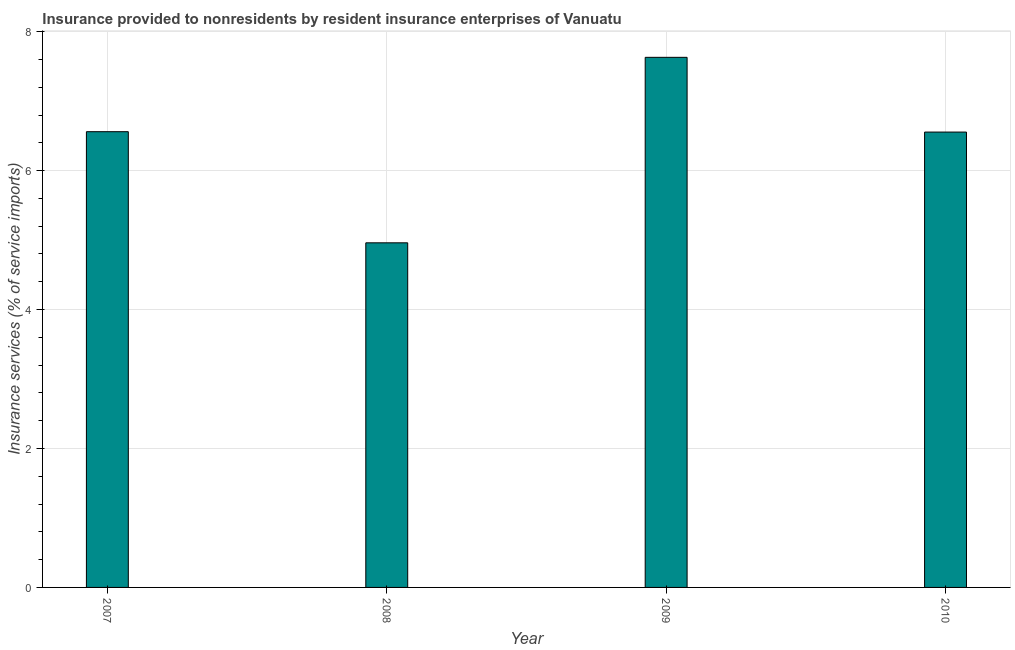Does the graph contain any zero values?
Offer a terse response. No. What is the title of the graph?
Make the answer very short. Insurance provided to nonresidents by resident insurance enterprises of Vanuatu. What is the label or title of the Y-axis?
Keep it short and to the point. Insurance services (% of service imports). What is the insurance and financial services in 2009?
Give a very brief answer. 7.63. Across all years, what is the maximum insurance and financial services?
Keep it short and to the point. 7.63. Across all years, what is the minimum insurance and financial services?
Offer a terse response. 4.96. In which year was the insurance and financial services minimum?
Provide a succinct answer. 2008. What is the sum of the insurance and financial services?
Your answer should be compact. 25.71. What is the difference between the insurance and financial services in 2007 and 2009?
Offer a terse response. -1.07. What is the average insurance and financial services per year?
Offer a very short reply. 6.43. What is the median insurance and financial services?
Offer a terse response. 6.56. Do a majority of the years between 2008 and 2009 (inclusive) have insurance and financial services greater than 5.6 %?
Give a very brief answer. No. What is the ratio of the insurance and financial services in 2007 to that in 2009?
Offer a terse response. 0.86. Is the insurance and financial services in 2008 less than that in 2010?
Give a very brief answer. Yes. What is the difference between the highest and the second highest insurance and financial services?
Your response must be concise. 1.07. Is the sum of the insurance and financial services in 2007 and 2009 greater than the maximum insurance and financial services across all years?
Your answer should be compact. Yes. What is the difference between the highest and the lowest insurance and financial services?
Keep it short and to the point. 2.67. How many bars are there?
Provide a short and direct response. 4. What is the difference between two consecutive major ticks on the Y-axis?
Your response must be concise. 2. What is the Insurance services (% of service imports) in 2007?
Provide a short and direct response. 6.56. What is the Insurance services (% of service imports) of 2008?
Offer a terse response. 4.96. What is the Insurance services (% of service imports) of 2009?
Your answer should be compact. 7.63. What is the Insurance services (% of service imports) in 2010?
Provide a succinct answer. 6.55. What is the difference between the Insurance services (% of service imports) in 2007 and 2008?
Your answer should be very brief. 1.6. What is the difference between the Insurance services (% of service imports) in 2007 and 2009?
Offer a very short reply. -1.07. What is the difference between the Insurance services (% of service imports) in 2007 and 2010?
Offer a very short reply. 0.01. What is the difference between the Insurance services (% of service imports) in 2008 and 2009?
Offer a terse response. -2.67. What is the difference between the Insurance services (% of service imports) in 2008 and 2010?
Give a very brief answer. -1.59. What is the difference between the Insurance services (% of service imports) in 2009 and 2010?
Give a very brief answer. 1.08. What is the ratio of the Insurance services (% of service imports) in 2007 to that in 2008?
Offer a terse response. 1.32. What is the ratio of the Insurance services (% of service imports) in 2007 to that in 2009?
Your answer should be compact. 0.86. What is the ratio of the Insurance services (% of service imports) in 2007 to that in 2010?
Make the answer very short. 1. What is the ratio of the Insurance services (% of service imports) in 2008 to that in 2009?
Your answer should be compact. 0.65. What is the ratio of the Insurance services (% of service imports) in 2008 to that in 2010?
Ensure brevity in your answer.  0.76. What is the ratio of the Insurance services (% of service imports) in 2009 to that in 2010?
Provide a succinct answer. 1.16. 